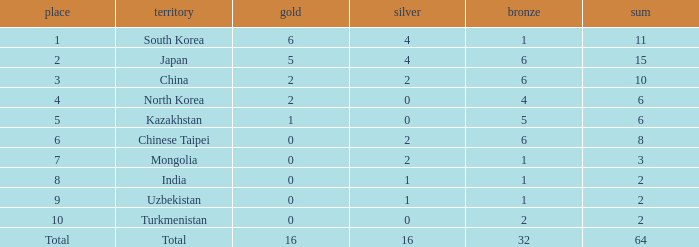What rank is Turkmenistan, who had 0 silver's and Less than 2 golds? 10.0. 